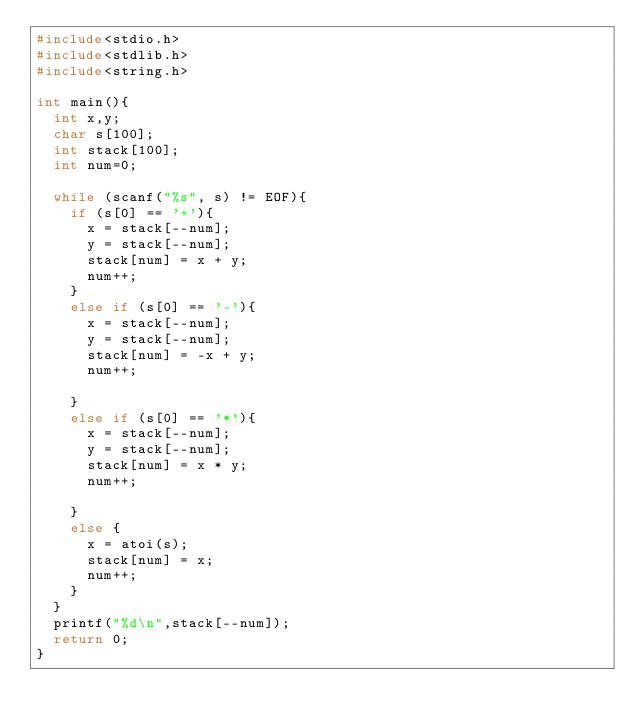Convert code to text. <code><loc_0><loc_0><loc_500><loc_500><_C_>#include<stdio.h>
#include<stdlib.h>
#include<string.h>

int main(){
	int x,y;
	char s[100];
	int stack[100];
	int num=0;

	while (scanf("%s", s) != EOF){
		if (s[0] == '+'){
			x = stack[--num];
			y = stack[--num];
			stack[num] = x + y; 
			num++;
		}
		else if (s[0] == '-'){
			x = stack[--num];
			y = stack[--num];
			stack[num] = -x + y;
			num++;

		}
		else if (s[0] == '*'){
			x = stack[--num];
			y = stack[--num];
			stack[num] = x * y;
			num++;

		}
		else {
			x = atoi(s);
			stack[num] = x;
			num++;
		}
	}
	printf("%d\n",stack[--num]);
	return 0;
}</code> 